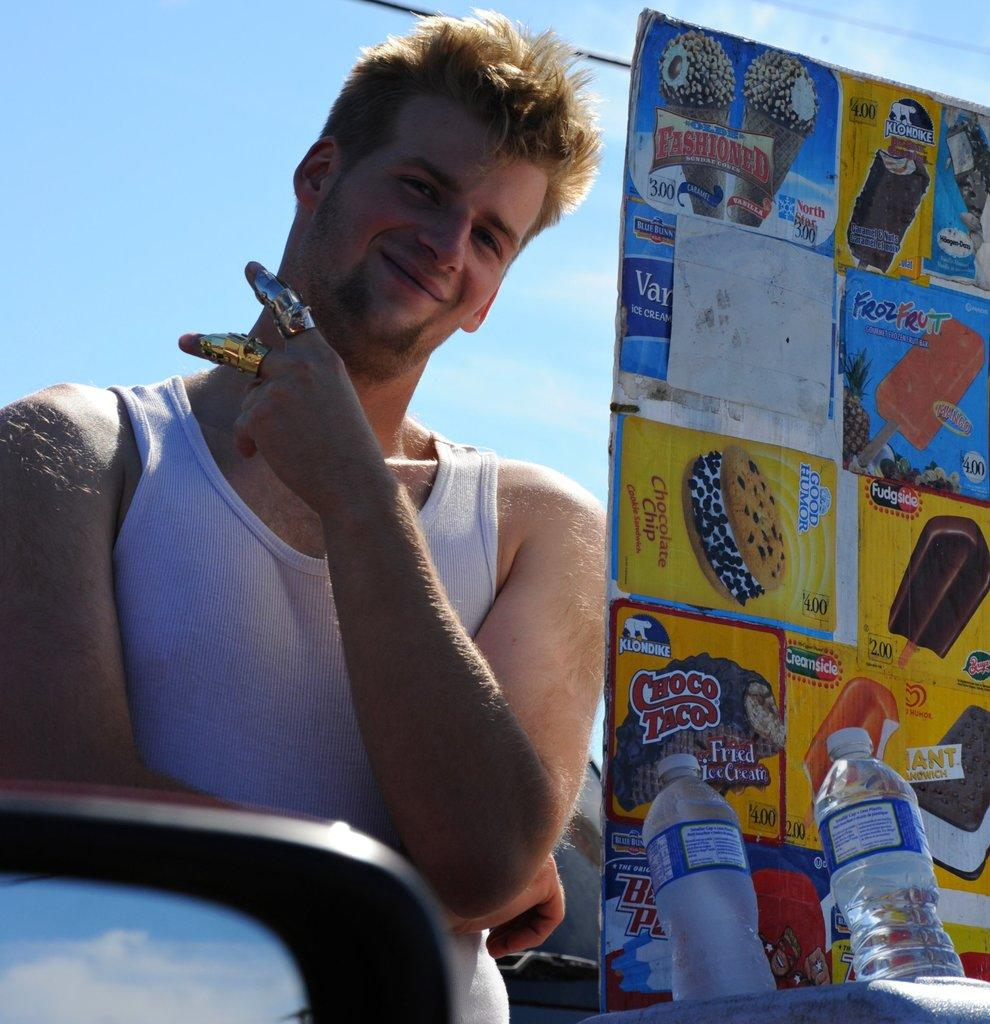What is the main subject of the image? The main subject of the image is a man. What is the man doing in the image? The man is standing in the image. What is the man's facial expression in the image? The man is smiling in the image. What else can be seen in the image besides the man? There are bottles and an object in the front of the image. What type of stick is the man holding in the image? There is no stick present in the image. Can you see a train in the background of the image? There is no train visible in the image. 